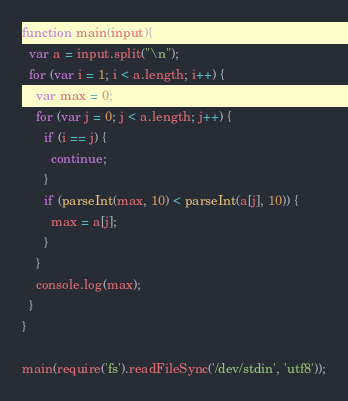<code> <loc_0><loc_0><loc_500><loc_500><_JavaScript_>function main(input){
  var a = input.split("\n");
  for (var i = 1; i < a.length; i++) {
    var max = 0;
    for (var j = 0; j < a.length; j++) {
      if (i == j) {
        continue;
      }
      if (parseInt(max, 10) < parseInt(a[j], 10)) {
        max = a[j];
      }
    }
    console.log(max);
  }
}
 
main(require('fs').readFileSync('/dev/stdin', 'utf8'));</code> 